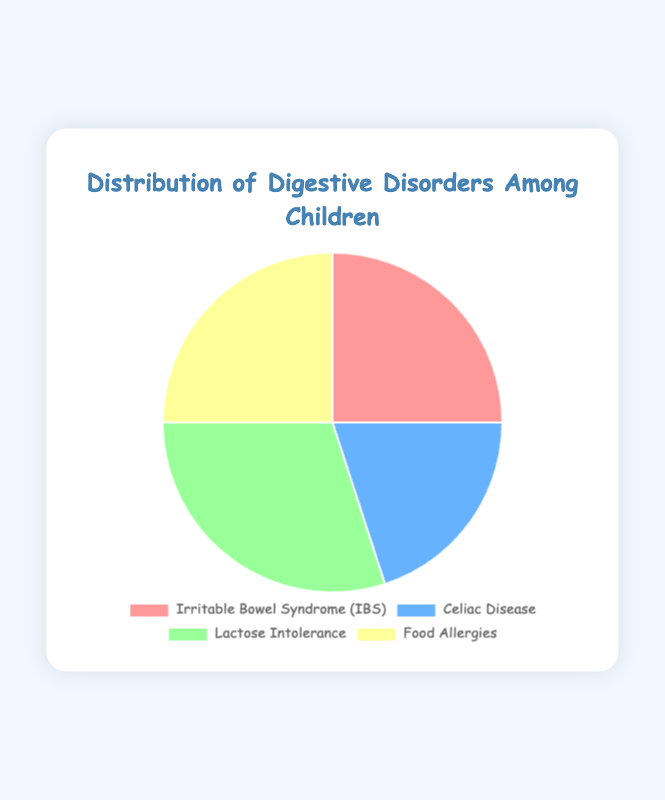What is the most common digestive disorder among children represented in the pie chart? By looking at the chart, we can see which segment is largest. The segment for Lactose Intolerance is the largest, indicating it is the most common disorder.
Answer: Lactose Intolerance Which digestive disorders share an equal percentage according to the pie chart? The chart has segments for IBS and Food Allergies that are equal in size, each representing 25%.
Answer: IBS and Food Allergies What percentage of children are suffering from Food Allergies? The pie chart shows that the segment for Food Allergies accounts for 25% of the whole chart.
Answer: 25% How much more prevalent is Lactose Intolerance compared to Celiac Disease? Lactose Intolerance accounts for 30% while Celiac Disease is 20%. The difference is 30% - 20%.
Answer: 10% If you sum the percentages of children with IBS and Celiac Disease, what is the total? IBS is 25% and Celiac Disease is 20%. Adding these gives us 25% + 20%.
Answer: 45% Which disorder is least common, and by how much does it differ from the most common one? The least common is Celiac Disease (20%) and the most common is Lactose Intolerance (30%). The difference is 30% - 20%.
Answer: Celiac Disease, 10% What is the combined percentage for IBS, Food Allergies, and Celiac Disease? Adding IBS (25%), Food Allergies (25%), and Celiac Disease (20%) results in 25% + 25% + 20%.
Answer: 70% Which segment of the pie chart is represented by the color red? By referring to the legend and visual attributes of the pie chart, the red segment corresponds to Irritable Bowel Syndrome (IBS).
Answer: Irritable Bowel Syndrome (IBS) If the total number of cases is 400, how many children have Lactose Intolerance? Lactose Intolerance is represented by 30% of the chart. Multiplying 30% by 400, we get 0.3 * 400.
Answer: 120 How does the percentage of IBS compare to the percentage of Lactose Intolerance? The pie chart shows IBS at 25% and Lactose Intolerance at 30%. Therefore, IBS is less common than Lactose Intolerance by 30% - 25%.
Answer: 5% less 